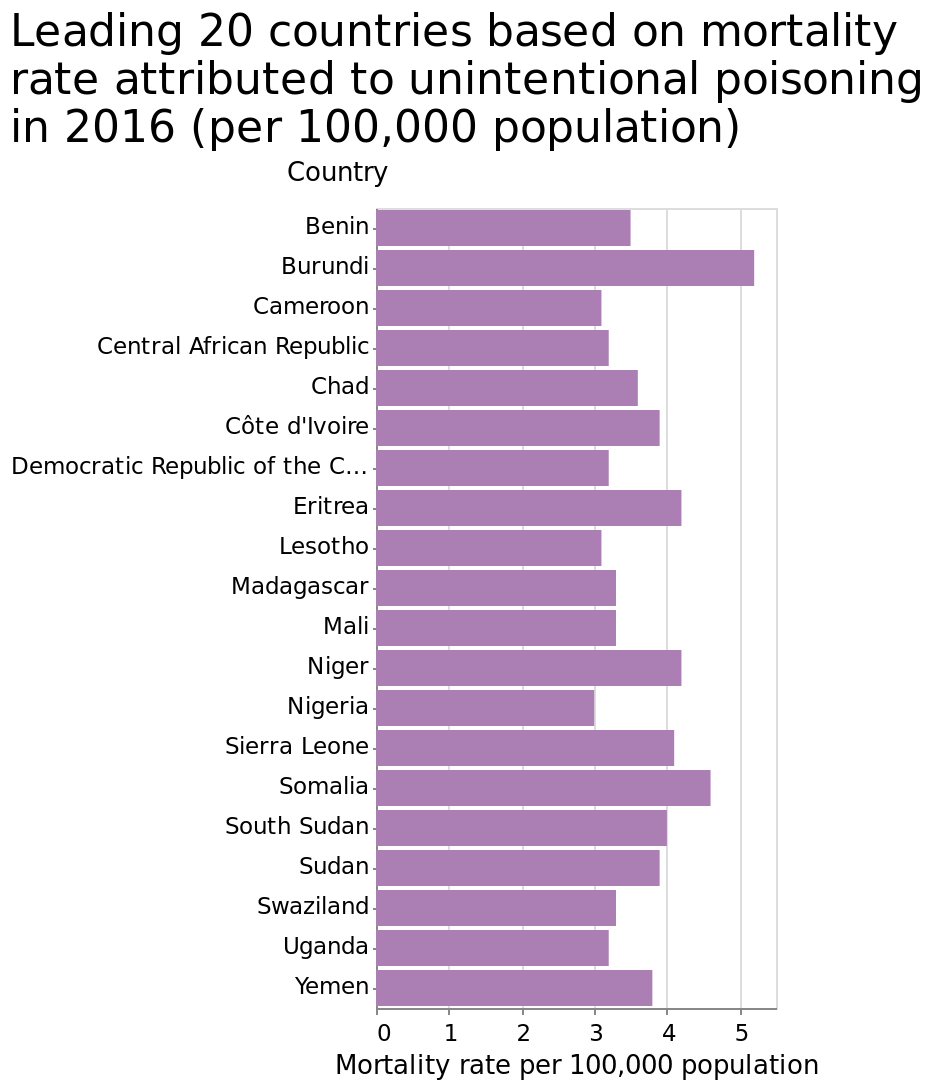<image>
please summary the statistics and relations of the chart A lot of the top 20 countries for mortality from accidental poisoning per 100,000 people are in Africa. Burundi has the highest rate of mortality from accidental poisoning. Which region has a high number of countries with mortality from accidental poisoning?  Africa  